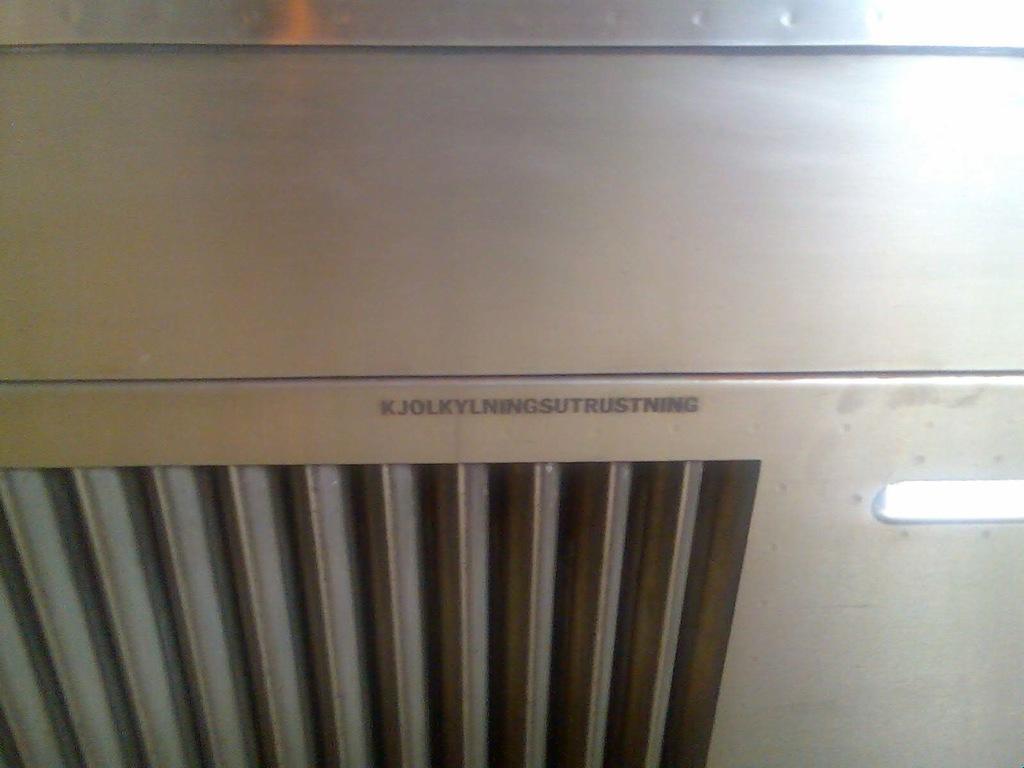What brand is the machine?
Your answer should be very brief. Kjolkylningsutrustning. 